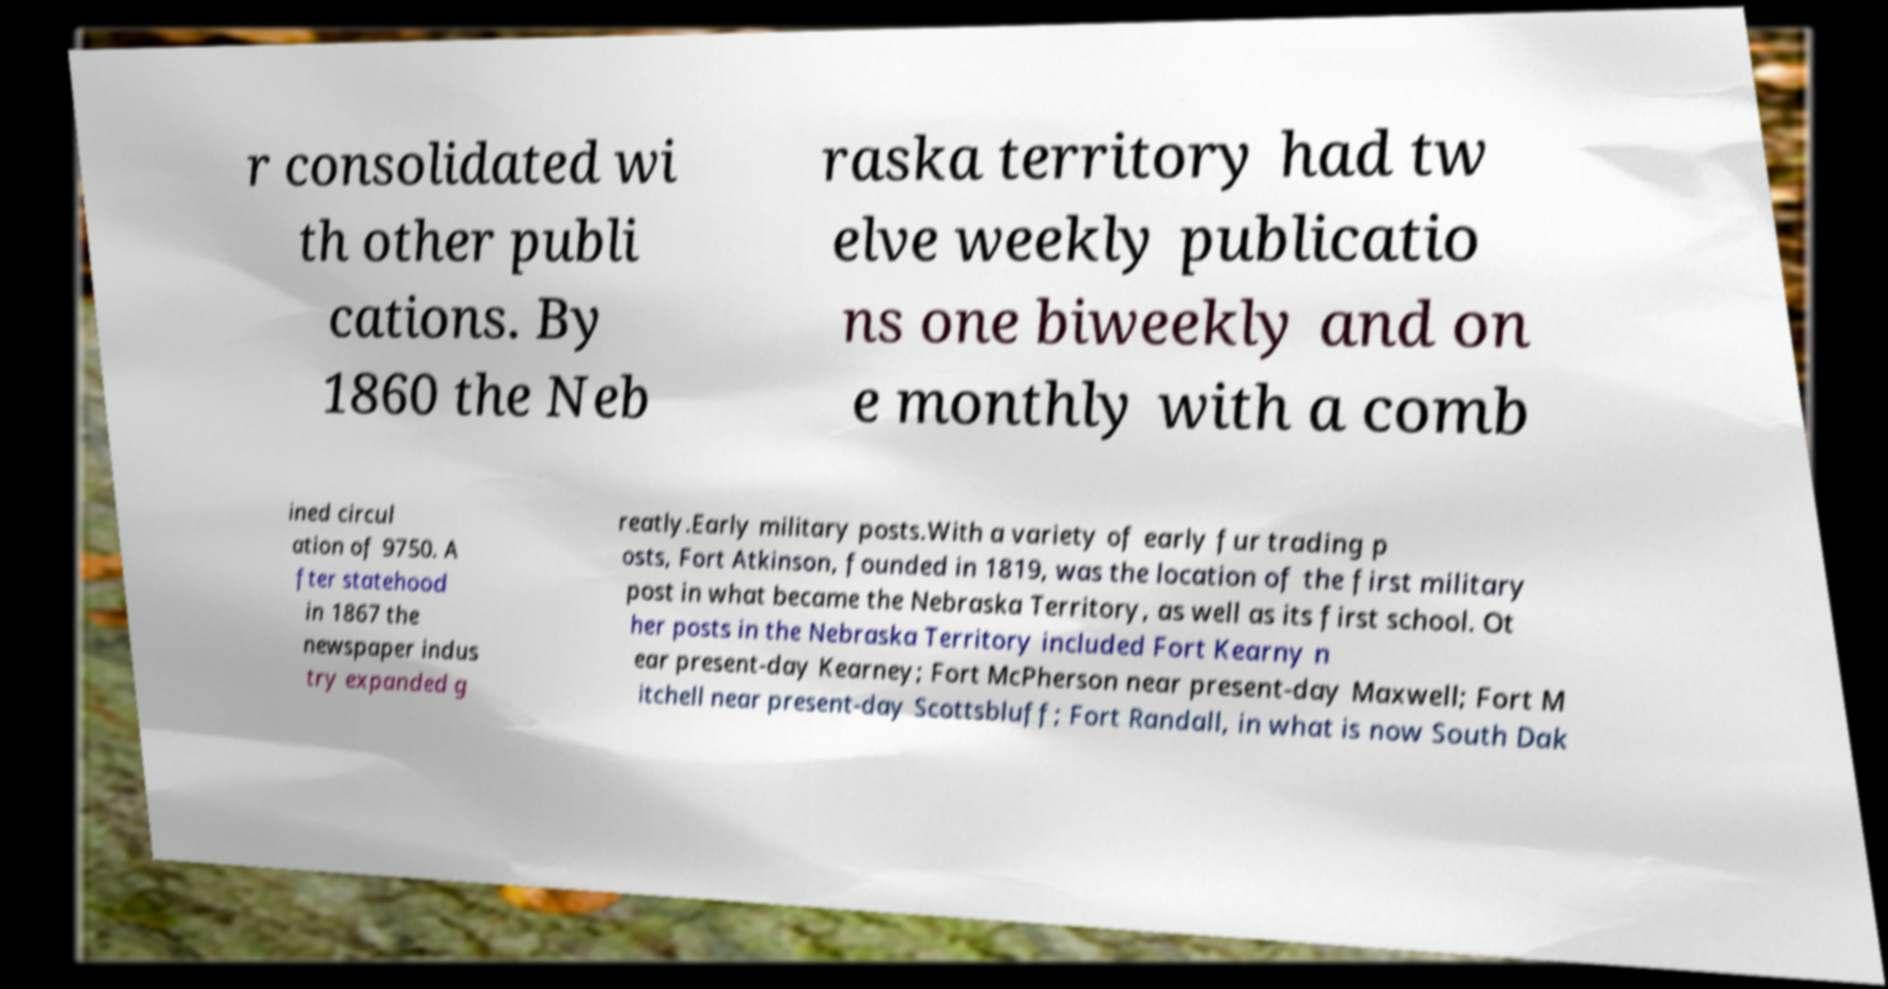Could you assist in decoding the text presented in this image and type it out clearly? r consolidated wi th other publi cations. By 1860 the Neb raska territory had tw elve weekly publicatio ns one biweekly and on e monthly with a comb ined circul ation of 9750. A fter statehood in 1867 the newspaper indus try expanded g reatly.Early military posts.With a variety of early fur trading p osts, Fort Atkinson, founded in 1819, was the location of the first military post in what became the Nebraska Territory, as well as its first school. Ot her posts in the Nebraska Territory included Fort Kearny n ear present-day Kearney; Fort McPherson near present-day Maxwell; Fort M itchell near present-day Scottsbluff; Fort Randall, in what is now South Dak 